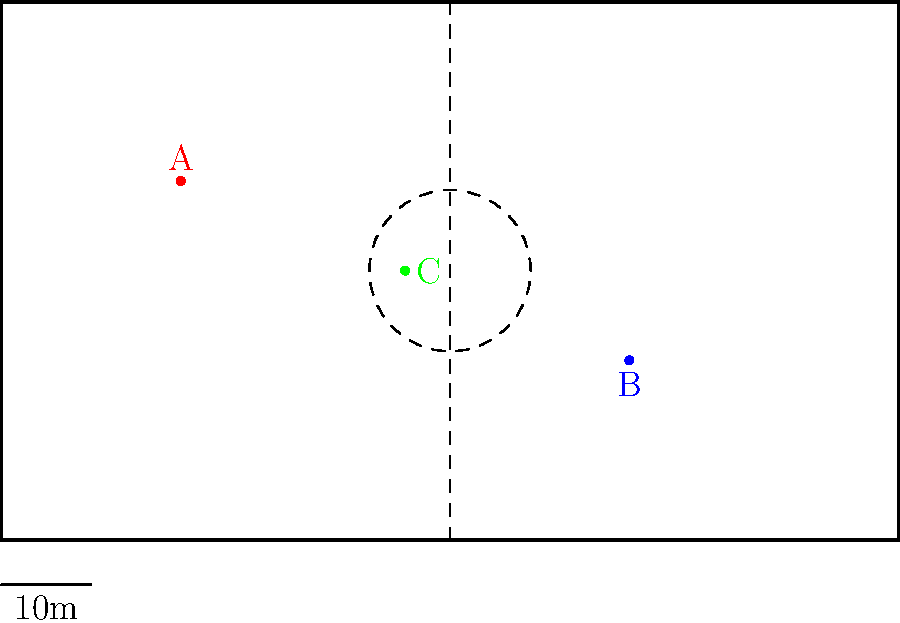On the scaled diagram of a football pitch, players A, B, and C are positioned as shown. The pitch is 100 meters long. Estimate the distance between players A and B to the nearest 5 meters. To estimate the distance between players A and B, we'll follow these steps:

1. Observe that the pitch is 100 meters long, which corresponds to the full width of the diagram.

2. Mentally divide the pitch into quarters (25m sections) to help with estimation.

3. Player A is approximately 20m from the left edge of the pitch.

4. Player B is about 70m from the left edge of the pitch.

5. The horizontal distance between A and B is therefore about 50m (70m - 20m).

6. For the vertical distance, we can see that A is near the top quarter line, while B is near the bottom quarter line. This vertical distance is approximately 20m.

7. To estimate the direct distance between A and B, we can use the Pythagorean theorem: $c^2 = a^2 + b^2$

8. Substituting our estimates: $c^2 = 50^2 + 20^2 = 2500 + 400 = 2900$

9. Taking the square root: $c \approx \sqrt{2900} \approx 53.85$

10. Rounding to the nearest 5 meters as requested: 55 meters.
Answer: 55 meters 